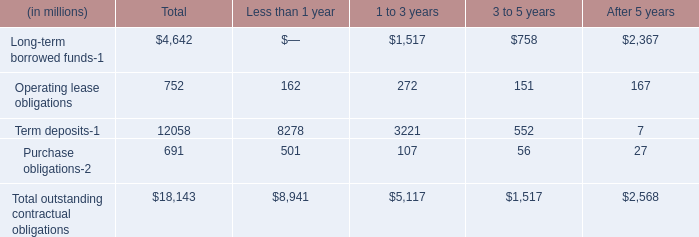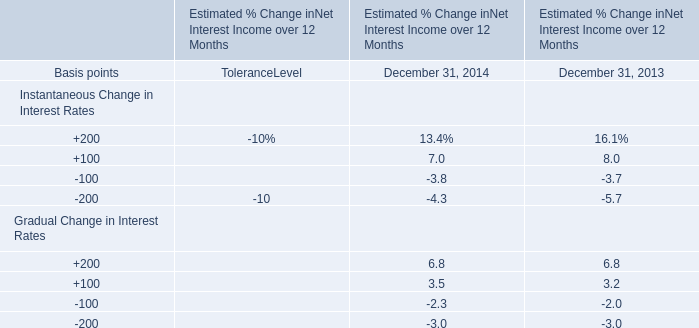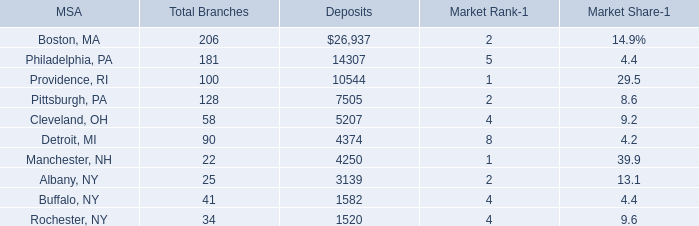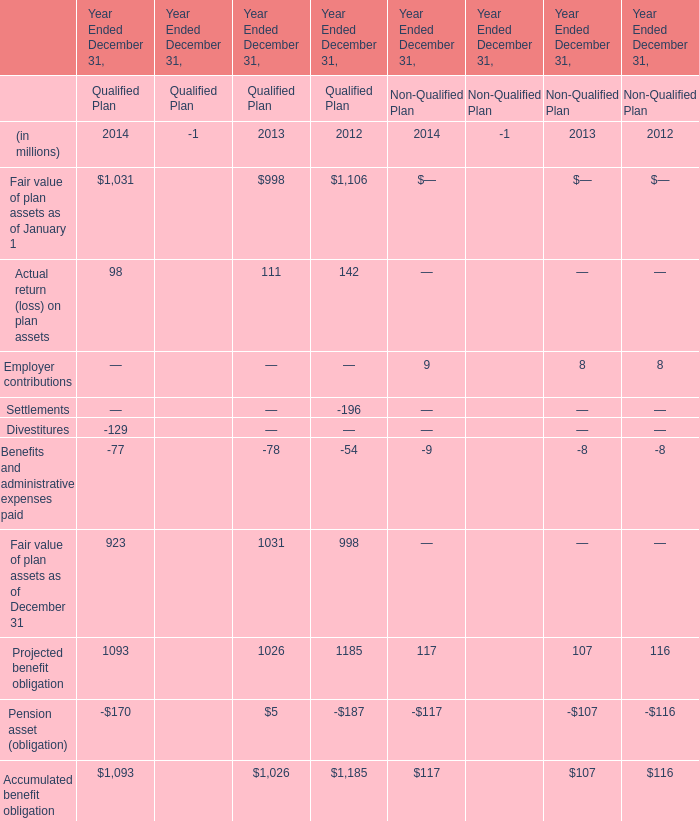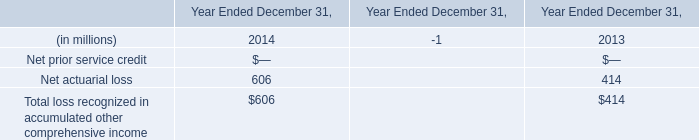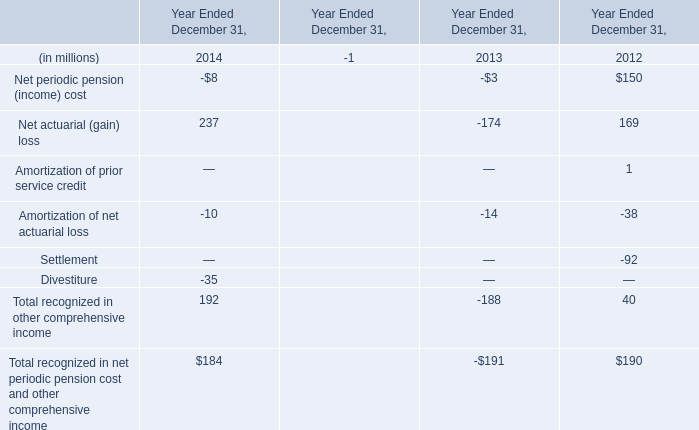Which year is Net actuarial (gain) loss the most? 
Answer: 2014. 